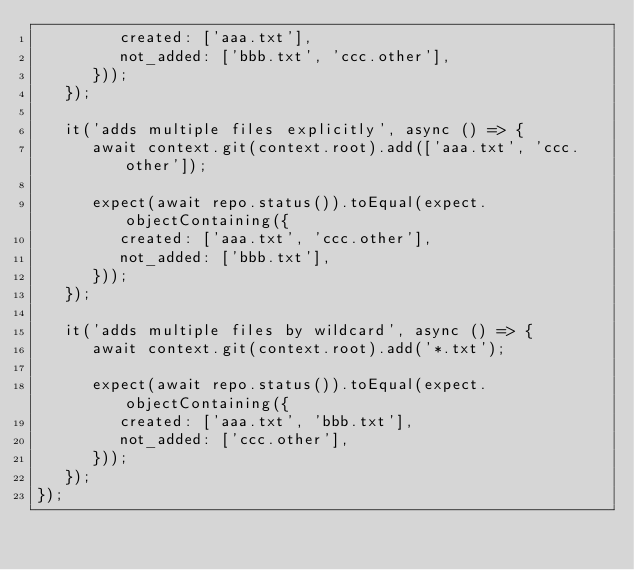Convert code to text. <code><loc_0><loc_0><loc_500><loc_500><_JavaScript_>         created: ['aaa.txt'],
         not_added: ['bbb.txt', 'ccc.other'],
      }));
   });

   it('adds multiple files explicitly', async () => {
      await context.git(context.root).add(['aaa.txt', 'ccc.other']);

      expect(await repo.status()).toEqual(expect.objectContaining({
         created: ['aaa.txt', 'ccc.other'],
         not_added: ['bbb.txt'],
      }));
   });

   it('adds multiple files by wildcard', async () => {
      await context.git(context.root).add('*.txt');

      expect(await repo.status()).toEqual(expect.objectContaining({
         created: ['aaa.txt', 'bbb.txt'],
         not_added: ['ccc.other'],
      }));
   });
});
</code> 